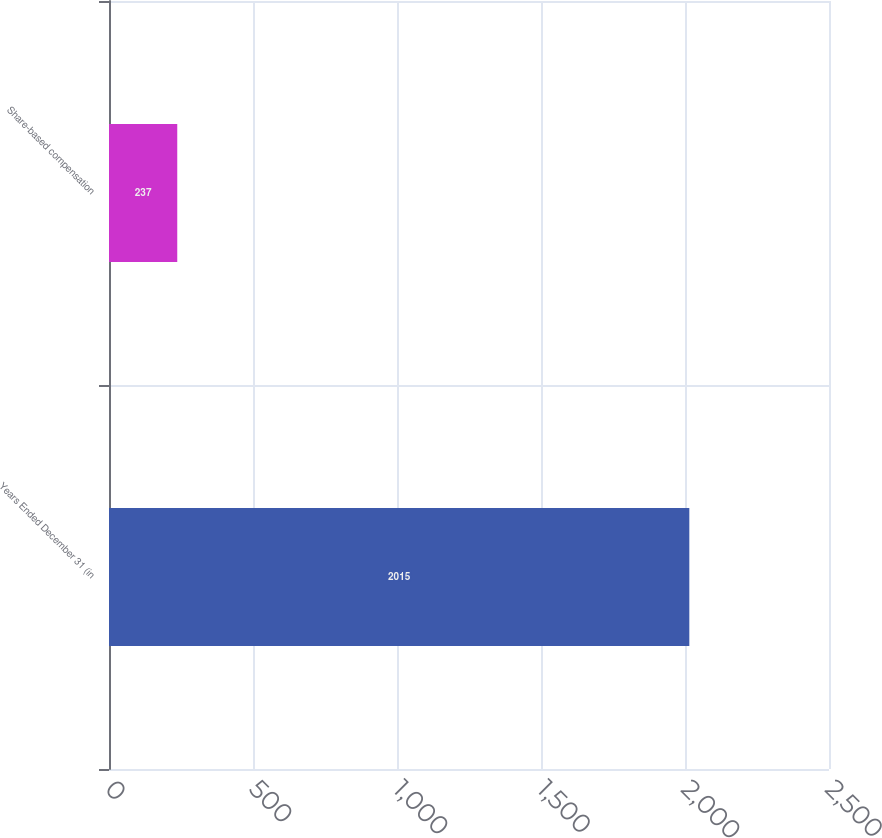Convert chart to OTSL. <chart><loc_0><loc_0><loc_500><loc_500><bar_chart><fcel>Years Ended December 31 (in<fcel>Share-based compensation<nl><fcel>2015<fcel>237<nl></chart> 